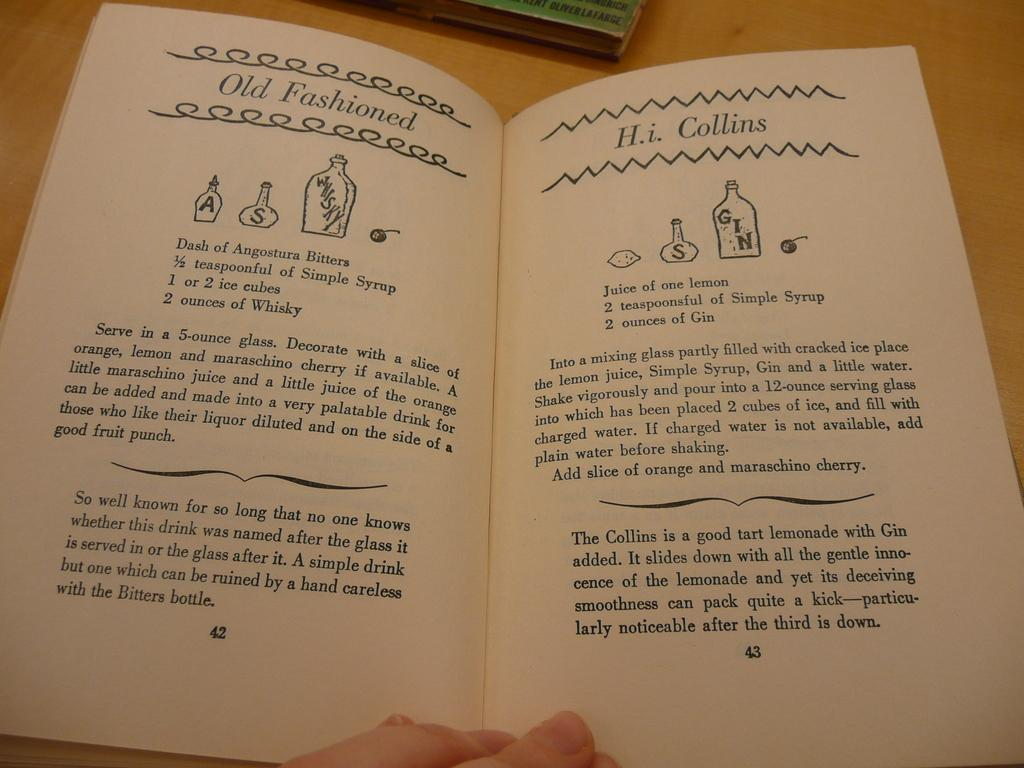What is the main object in the image? There is a table in the image. What is placed on the table? There are books on the table. Can you describe any body parts visible in the image? A person's fingers are visible at the bottom of the image. What type of tooth is being used to turn the pages of the books in the image? There is no tooth present in the image, and the books are not being turned. 